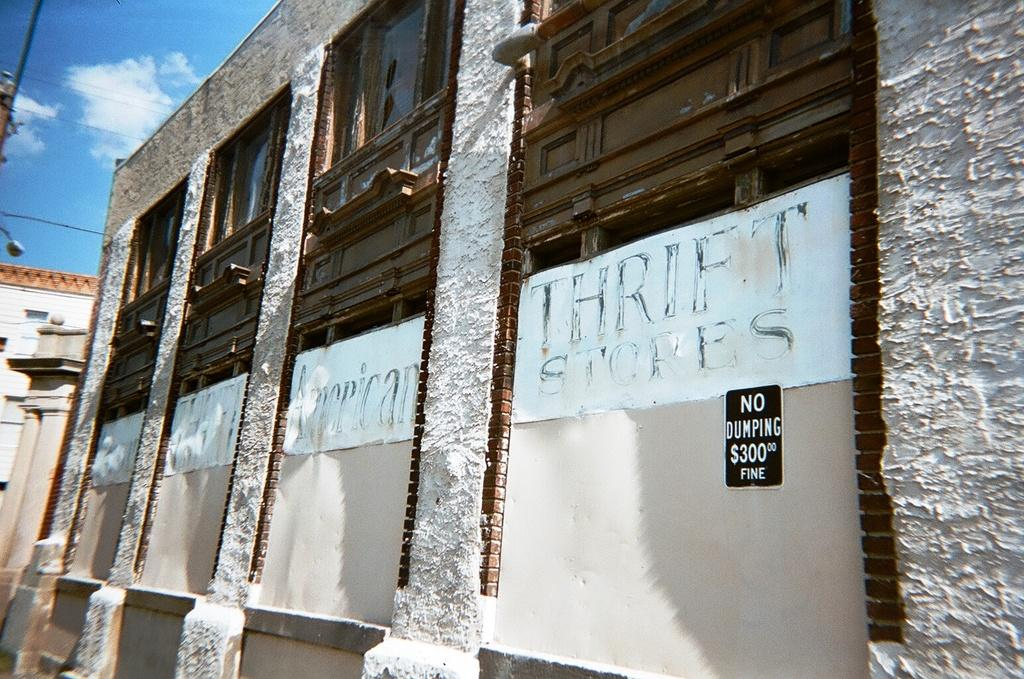What type of structures can be seen in the image? There are buildings in the image. What other objects are present in the image? There are posters and a board visible in the image. What is visible in the background of the image? The sky is visible in the background of the image. Can you describe the sky in the image? The sky has clouds in the image. What type of scarf is being used to create a rhythm in the image? There is no scarf or rhythm present in the image. Can you describe the coastline visible in the image? There is no coastline visible in the image; it features buildings, posters, a board, and a sky with clouds. 